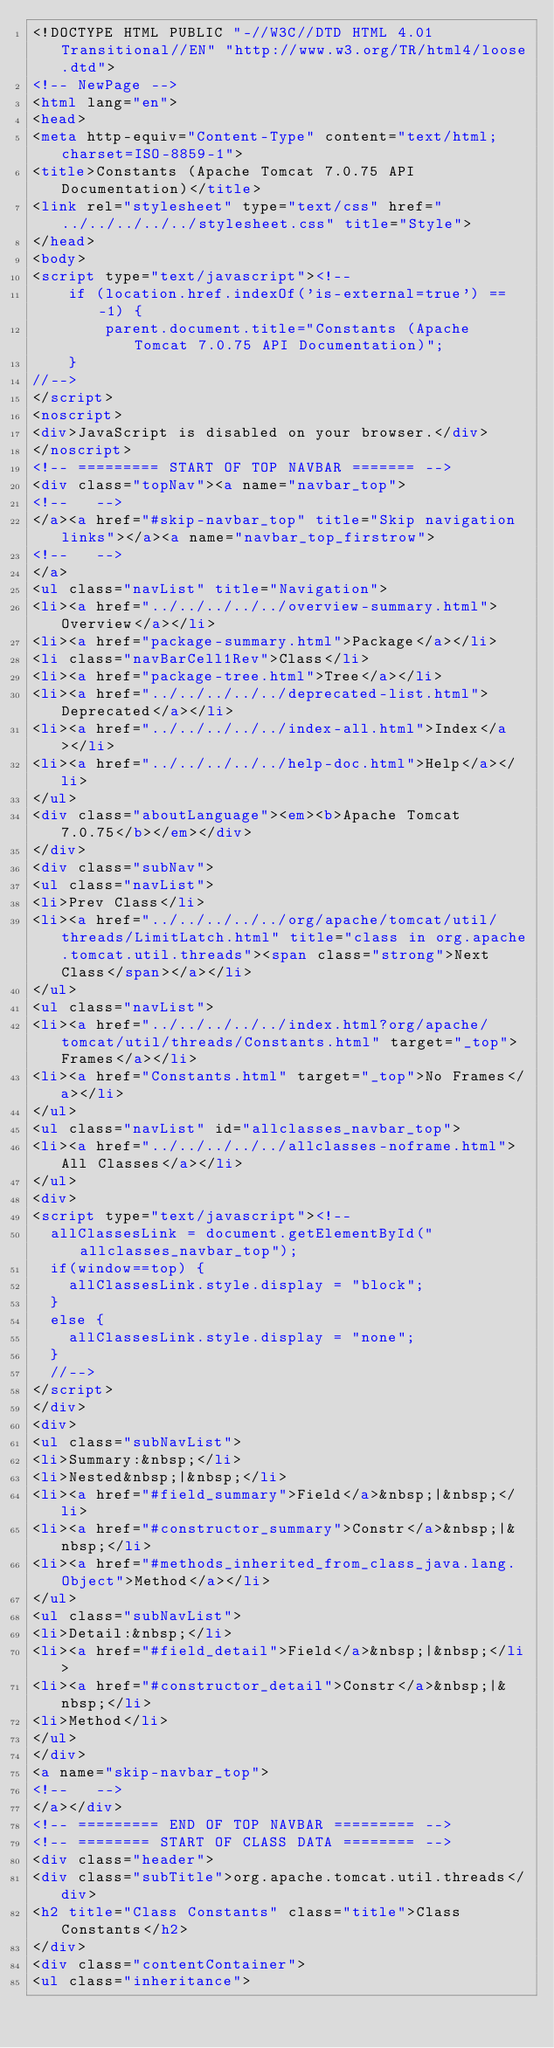Convert code to text. <code><loc_0><loc_0><loc_500><loc_500><_HTML_><!DOCTYPE HTML PUBLIC "-//W3C//DTD HTML 4.01 Transitional//EN" "http://www.w3.org/TR/html4/loose.dtd">
<!-- NewPage -->
<html lang="en">
<head>
<meta http-equiv="Content-Type" content="text/html; charset=ISO-8859-1">
<title>Constants (Apache Tomcat 7.0.75 API Documentation)</title>
<link rel="stylesheet" type="text/css" href="../../../../../stylesheet.css" title="Style">
</head>
<body>
<script type="text/javascript"><!--
    if (location.href.indexOf('is-external=true') == -1) {
        parent.document.title="Constants (Apache Tomcat 7.0.75 API Documentation)";
    }
//-->
</script>
<noscript>
<div>JavaScript is disabled on your browser.</div>
</noscript>
<!-- ========= START OF TOP NAVBAR ======= -->
<div class="topNav"><a name="navbar_top">
<!--   -->
</a><a href="#skip-navbar_top" title="Skip navigation links"></a><a name="navbar_top_firstrow">
<!--   -->
</a>
<ul class="navList" title="Navigation">
<li><a href="../../../../../overview-summary.html">Overview</a></li>
<li><a href="package-summary.html">Package</a></li>
<li class="navBarCell1Rev">Class</li>
<li><a href="package-tree.html">Tree</a></li>
<li><a href="../../../../../deprecated-list.html">Deprecated</a></li>
<li><a href="../../../../../index-all.html">Index</a></li>
<li><a href="../../../../../help-doc.html">Help</a></li>
</ul>
<div class="aboutLanguage"><em><b>Apache Tomcat 7.0.75</b></em></div>
</div>
<div class="subNav">
<ul class="navList">
<li>Prev Class</li>
<li><a href="../../../../../org/apache/tomcat/util/threads/LimitLatch.html" title="class in org.apache.tomcat.util.threads"><span class="strong">Next Class</span></a></li>
</ul>
<ul class="navList">
<li><a href="../../../../../index.html?org/apache/tomcat/util/threads/Constants.html" target="_top">Frames</a></li>
<li><a href="Constants.html" target="_top">No Frames</a></li>
</ul>
<ul class="navList" id="allclasses_navbar_top">
<li><a href="../../../../../allclasses-noframe.html">All Classes</a></li>
</ul>
<div>
<script type="text/javascript"><!--
  allClassesLink = document.getElementById("allclasses_navbar_top");
  if(window==top) {
    allClassesLink.style.display = "block";
  }
  else {
    allClassesLink.style.display = "none";
  }
  //-->
</script>
</div>
<div>
<ul class="subNavList">
<li>Summary:&nbsp;</li>
<li>Nested&nbsp;|&nbsp;</li>
<li><a href="#field_summary">Field</a>&nbsp;|&nbsp;</li>
<li><a href="#constructor_summary">Constr</a>&nbsp;|&nbsp;</li>
<li><a href="#methods_inherited_from_class_java.lang.Object">Method</a></li>
</ul>
<ul class="subNavList">
<li>Detail:&nbsp;</li>
<li><a href="#field_detail">Field</a>&nbsp;|&nbsp;</li>
<li><a href="#constructor_detail">Constr</a>&nbsp;|&nbsp;</li>
<li>Method</li>
</ul>
</div>
<a name="skip-navbar_top">
<!--   -->
</a></div>
<!-- ========= END OF TOP NAVBAR ========= -->
<!-- ======== START OF CLASS DATA ======== -->
<div class="header">
<div class="subTitle">org.apache.tomcat.util.threads</div>
<h2 title="Class Constants" class="title">Class Constants</h2>
</div>
<div class="contentContainer">
<ul class="inheritance"></code> 